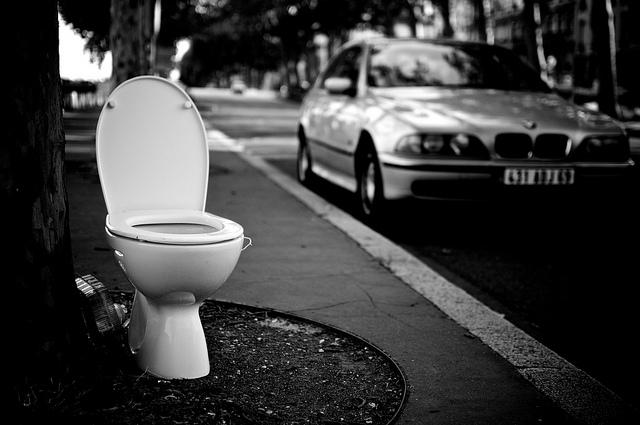Is there traffic?
Write a very short answer. No. Is the toilet usable?
Quick response, please. No. Is that an American license plate?
Keep it brief. No. Why is there a toilet on the sidewalk?
Answer briefly. Trash. 